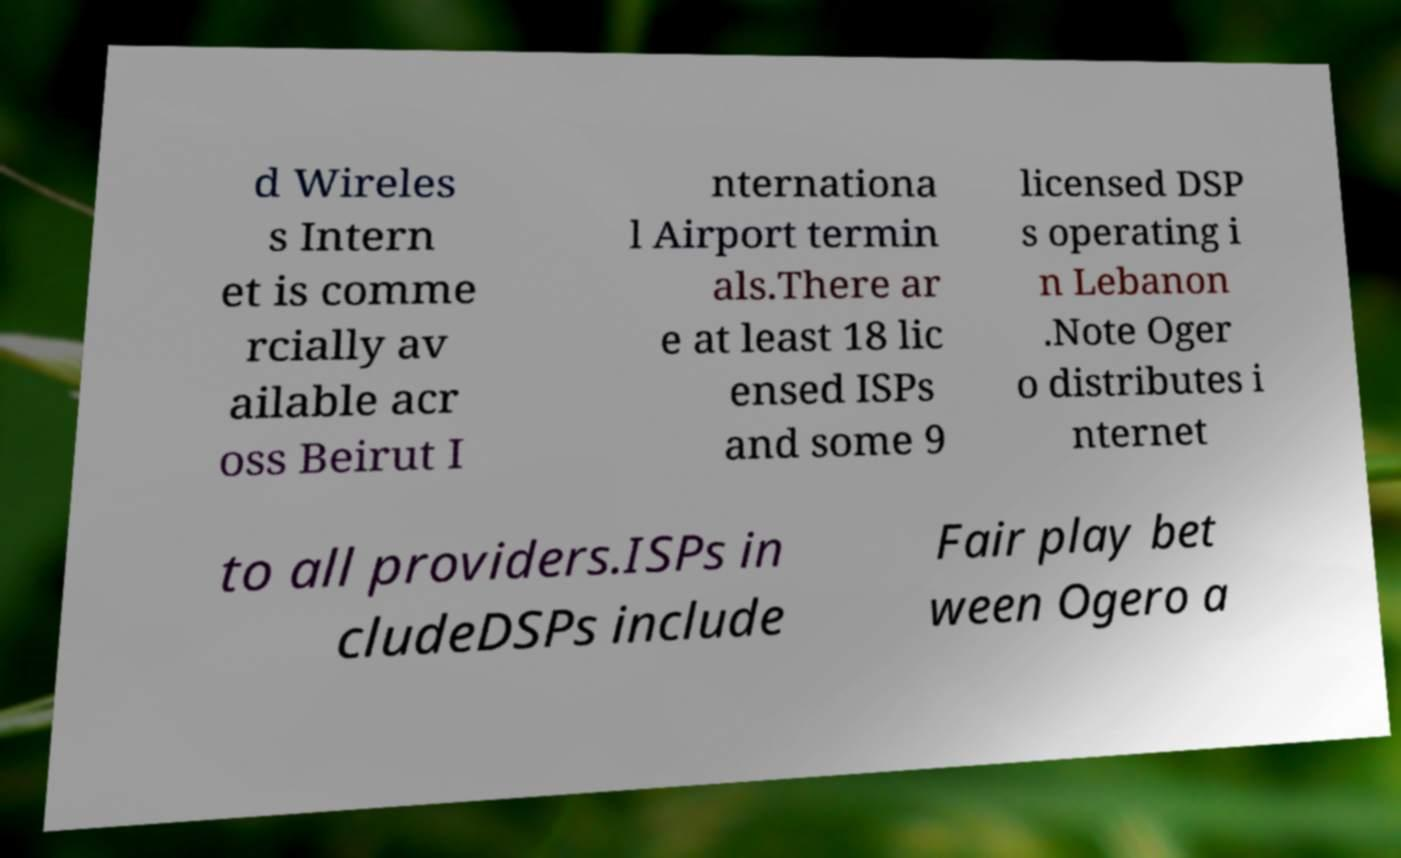For documentation purposes, I need the text within this image transcribed. Could you provide that? d Wireles s Intern et is comme rcially av ailable acr oss Beirut I nternationa l Airport termin als.There ar e at least 18 lic ensed ISPs and some 9 licensed DSP s operating i n Lebanon .Note Oger o distributes i nternet to all providers.ISPs in cludeDSPs include Fair play bet ween Ogero a 